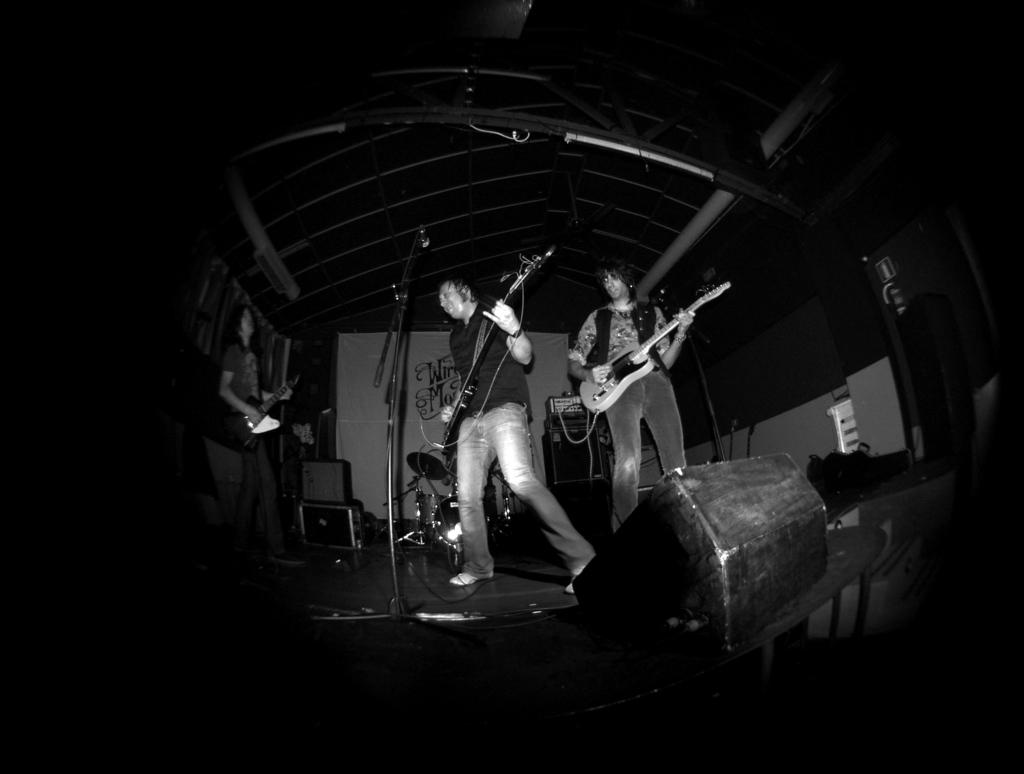How many people are the people are present in the image? There are three people in the image. What are the people doing in the image? The people are standing and playing a guitar. What object is present in the image that is typically used for amplifying sound? There is a microphone in the image. What type of support structure is visible in the image? There is a stand in the image. Can you see any dinosaurs or horses in the image? No, there are no dinosaurs or horses present in the image. What type of curtain is hanging from the stand in the image? There is no curtain present in the image; only a stand and other objects related to music can be seen. 